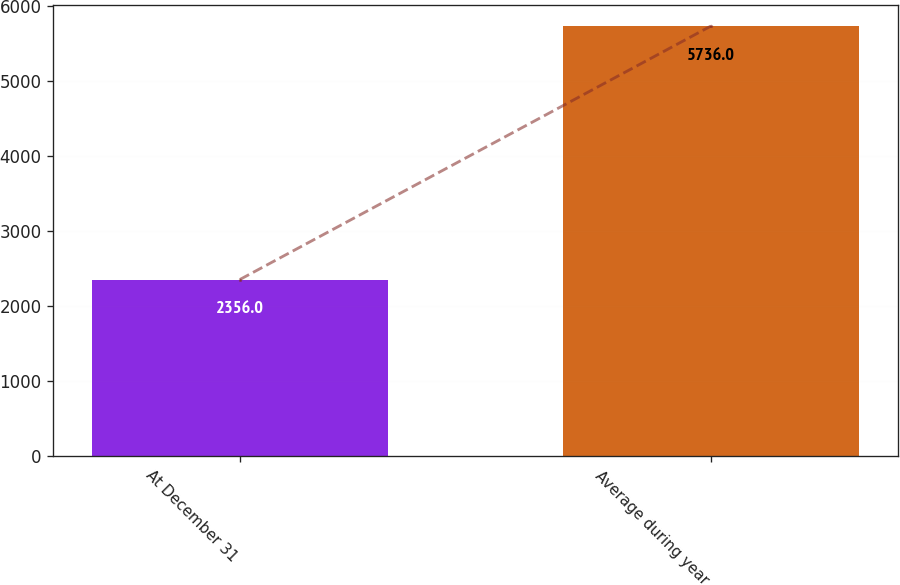Convert chart to OTSL. <chart><loc_0><loc_0><loc_500><loc_500><bar_chart><fcel>At December 31<fcel>Average during year<nl><fcel>2356<fcel>5736<nl></chart> 